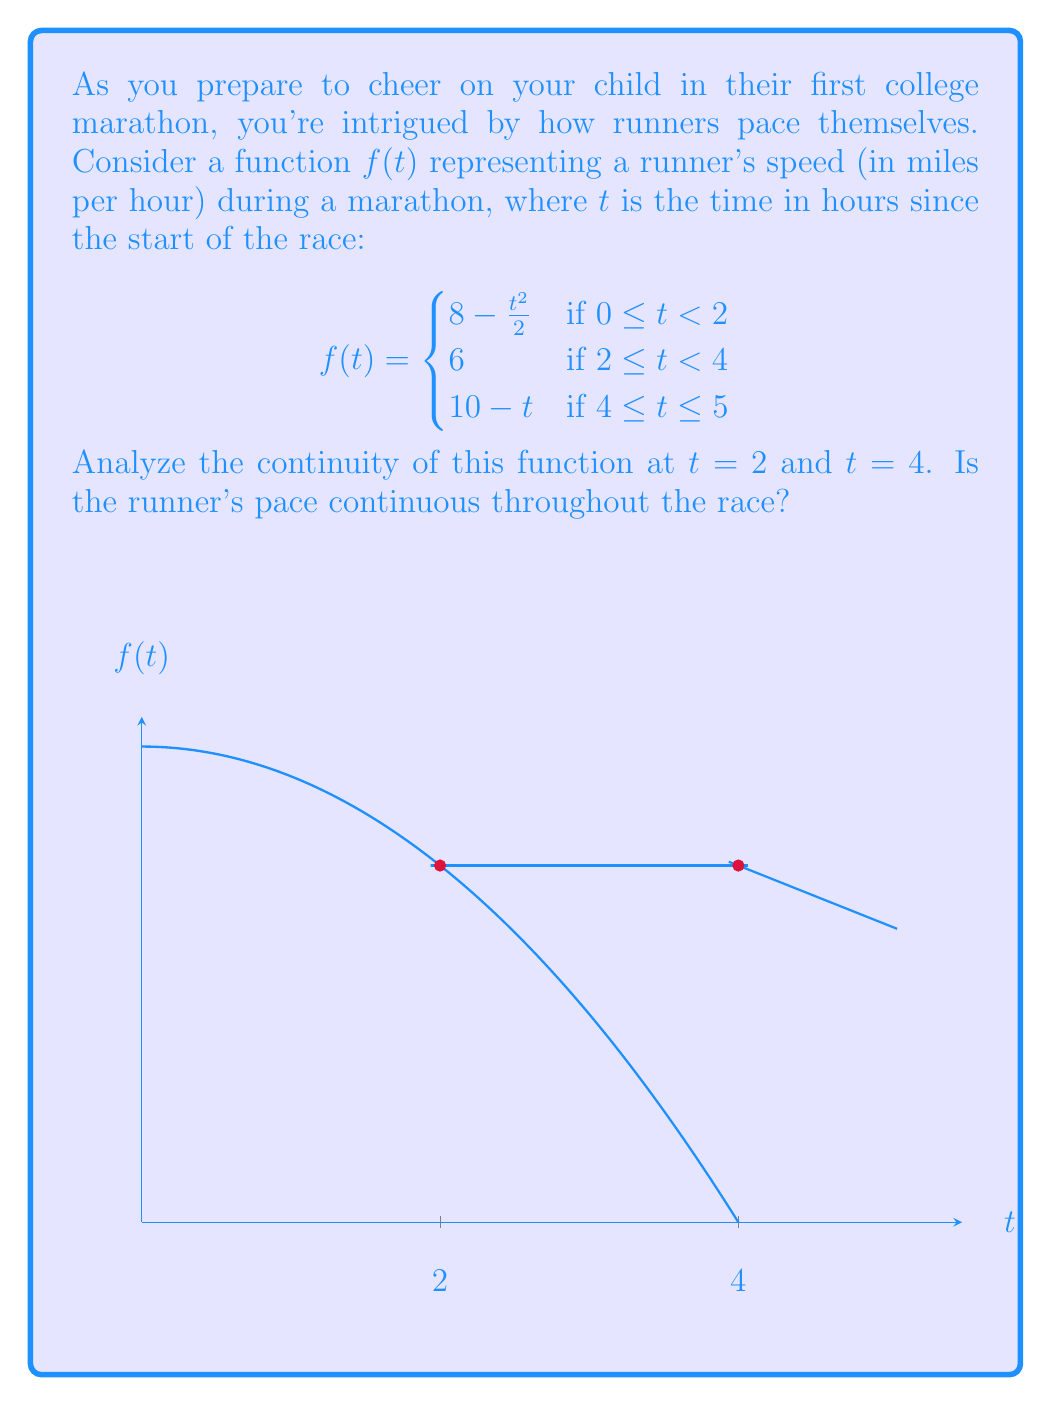Teach me how to tackle this problem. To analyze the continuity of $f(t)$ at $t = 2$ and $t = 4$, we need to check three conditions at each point:
1. The function is defined at the point.
2. The limit of the function as we approach the point from both sides exists.
3. The limit equals the function value at that point.

For $t = 2$:
1. $f(2)$ is defined and equals 6.
2. Left-hand limit: 
   $\lim_{t \to 2^-} f(t) = \lim_{t \to 2^-} (8 - \frac{t^2}{2}) = 8 - \frac{2^2}{2} = 6$
   Right-hand limit: 
   $\lim_{t \to 2^+} f(t) = 6$
3. Both limits equal $f(2) = 6$

Therefore, $f(t)$ is continuous at $t = 2$.

For $t = 4$:
1. $f(4)$ is defined and equals 6.
2. Left-hand limit: 
   $\lim_{t \to 4^-} f(t) = 6$
   Right-hand limit: 
   $\lim_{t \to 4^+} f(t) = \lim_{t \to 4^+} (10 - t) = 6$
3. Both limits equal $f(4) = 6$

Therefore, $f(t)$ is continuous at $t = 4$.

Since $f(t)$ is continuous at both $t = 2$ and $t = 4$, and it's composed of continuous functions within each interval, we can conclude that $f(t)$ is continuous over its entire domain $[0, 5]$.
Answer: The function $f(t)$ is continuous at both $t = 2$ and $t = 4$, and throughout the entire race. 